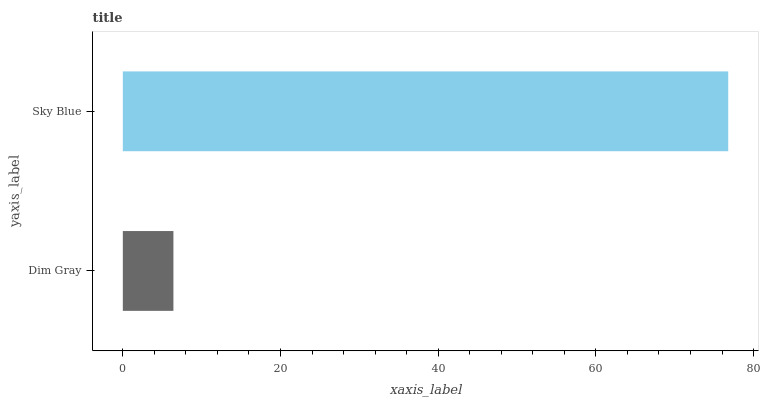Is Dim Gray the minimum?
Answer yes or no. Yes. Is Sky Blue the maximum?
Answer yes or no. Yes. Is Sky Blue the minimum?
Answer yes or no. No. Is Sky Blue greater than Dim Gray?
Answer yes or no. Yes. Is Dim Gray less than Sky Blue?
Answer yes or no. Yes. Is Dim Gray greater than Sky Blue?
Answer yes or no. No. Is Sky Blue less than Dim Gray?
Answer yes or no. No. Is Sky Blue the high median?
Answer yes or no. Yes. Is Dim Gray the low median?
Answer yes or no. Yes. Is Dim Gray the high median?
Answer yes or no. No. Is Sky Blue the low median?
Answer yes or no. No. 